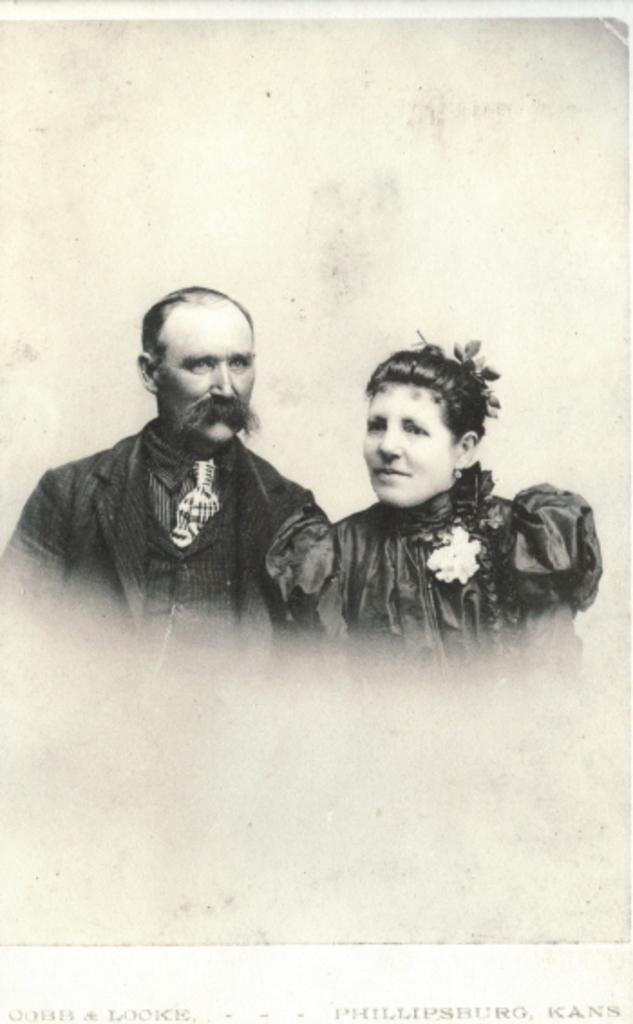How would you summarize this image in a sentence or two? Here, we can see a picture, there is a man and a woman on the picture. 